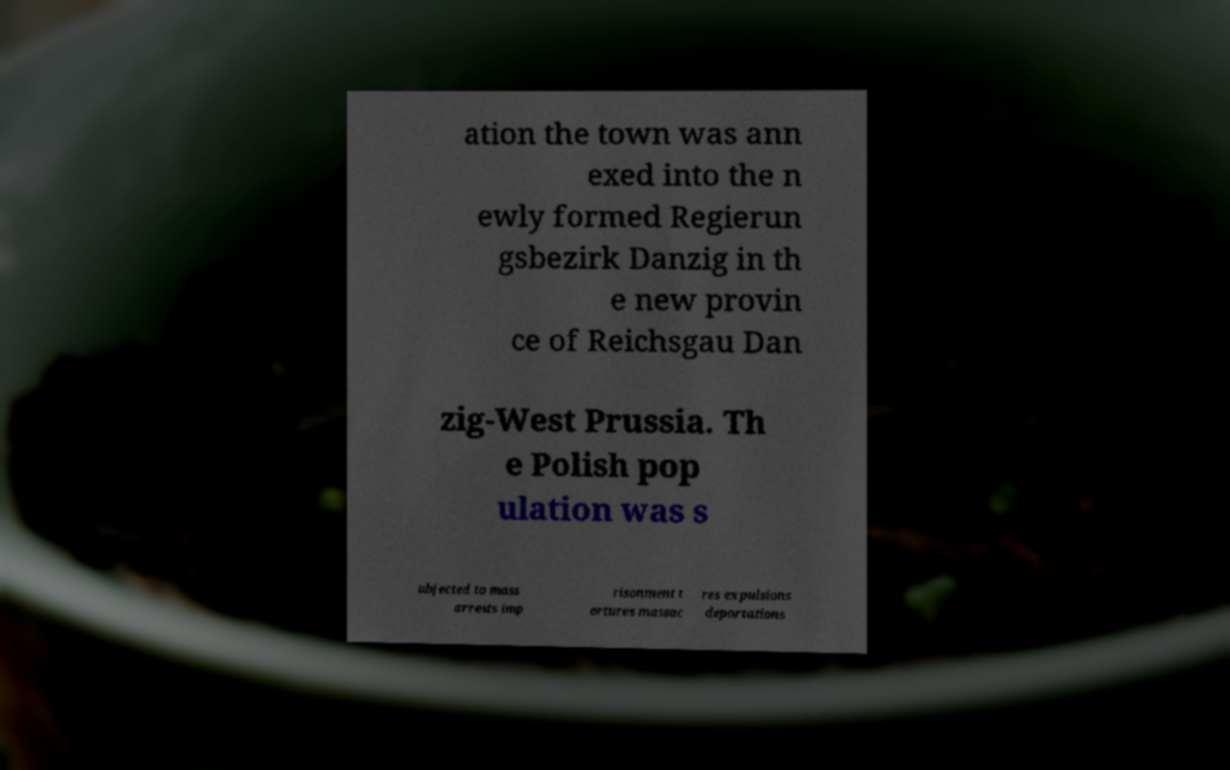There's text embedded in this image that I need extracted. Can you transcribe it verbatim? ation the town was ann exed into the n ewly formed Regierun gsbezirk Danzig in th e new provin ce of Reichsgau Dan zig-West Prussia. Th e Polish pop ulation was s ubjected to mass arrests imp risonment t ortures massac res expulsions deportations 